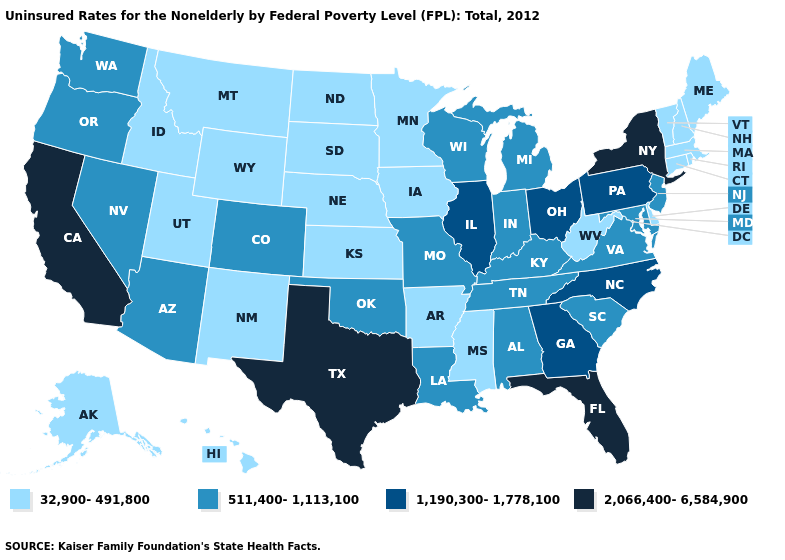What is the lowest value in the South?
Keep it brief. 32,900-491,800. Which states have the highest value in the USA?
Answer briefly. California, Florida, New York, Texas. What is the value of Michigan?
Write a very short answer. 511,400-1,113,100. What is the value of New Mexico?
Give a very brief answer. 32,900-491,800. What is the value of Ohio?
Be succinct. 1,190,300-1,778,100. What is the highest value in states that border Louisiana?
Concise answer only. 2,066,400-6,584,900. Which states have the highest value in the USA?
Short answer required. California, Florida, New York, Texas. What is the highest value in the MidWest ?
Short answer required. 1,190,300-1,778,100. What is the value of Connecticut?
Concise answer only. 32,900-491,800. What is the highest value in the MidWest ?
Concise answer only. 1,190,300-1,778,100. What is the value of North Carolina?
Quick response, please. 1,190,300-1,778,100. What is the lowest value in the USA?
Be succinct. 32,900-491,800. Name the states that have a value in the range 32,900-491,800?
Keep it brief. Alaska, Arkansas, Connecticut, Delaware, Hawaii, Idaho, Iowa, Kansas, Maine, Massachusetts, Minnesota, Mississippi, Montana, Nebraska, New Hampshire, New Mexico, North Dakota, Rhode Island, South Dakota, Utah, Vermont, West Virginia, Wyoming. Does Florida have the highest value in the South?
Be succinct. Yes. Name the states that have a value in the range 1,190,300-1,778,100?
Quick response, please. Georgia, Illinois, North Carolina, Ohio, Pennsylvania. 